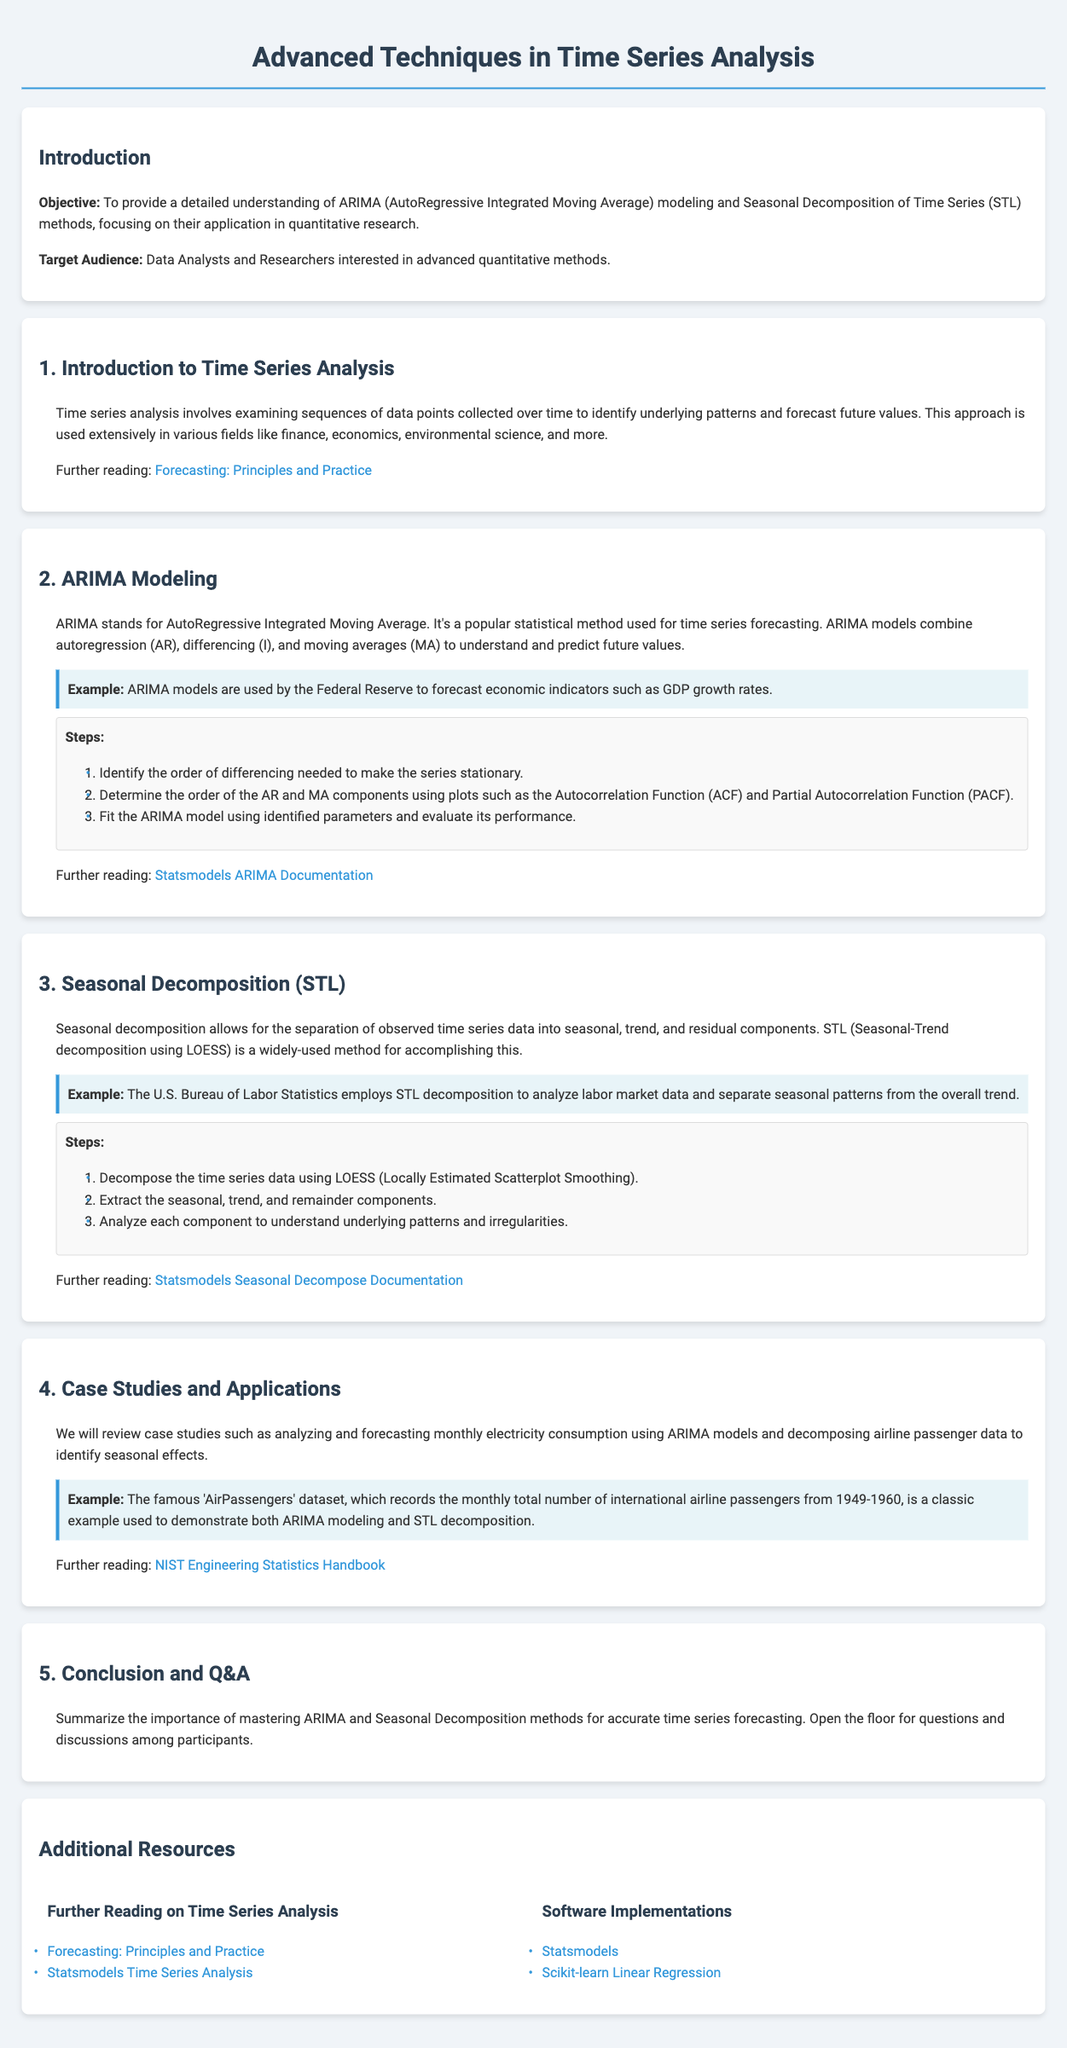What is the objective of the lesson? The objective is to provide a detailed understanding of ARIMA modeling and Seasonal Decomposition methods.
Answer: detailed understanding of ARIMA modeling and Seasonal Decomposition methods Who is the target audience? The target audience includes Data Analysts and Researchers interested in advanced quantitative methods.
Answer: Data Analysts and Researchers What does ARIMA stand for? ARIMA stands for AutoRegressive Integrated Moving Average.
Answer: AutoRegressive Integrated Moving Average What is the first step in ARIMA modeling? The first step is to identify the order of differencing needed to make the series stationary.
Answer: identify the order of differencing needed to make the series stationary What technique does STL use for decomposition? STL uses LOESS (Locally Estimated Scatterplot Smoothing) for decomposition.
Answer: LOESS Give an example of a case study mentioned in the document. The document mentions analyzing and forecasting monthly electricity consumption using ARIMA models.
Answer: analyzing and forecasting monthly electricity consumption using ARIMA models What is one of the additional resources listed for further reading? One of the additional resources is "Forecasting: Principles and Practice".
Answer: "Forecasting: Principles and Practice" What method is used by the U.S. Bureau of Labor Statistics as per the document? The U.S. Bureau of Labor Statistics uses STL decomposition.
Answer: STL decomposition How many steps are there in the ARIMA modeling process? There are three steps outlined in the ARIMA modeling process.
Answer: three steps 